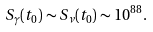<formula> <loc_0><loc_0><loc_500><loc_500>S _ { \gamma } ( t _ { 0 } ) \sim S _ { \nu } ( t _ { 0 } ) \sim 1 0 ^ { 8 8 } .</formula> 